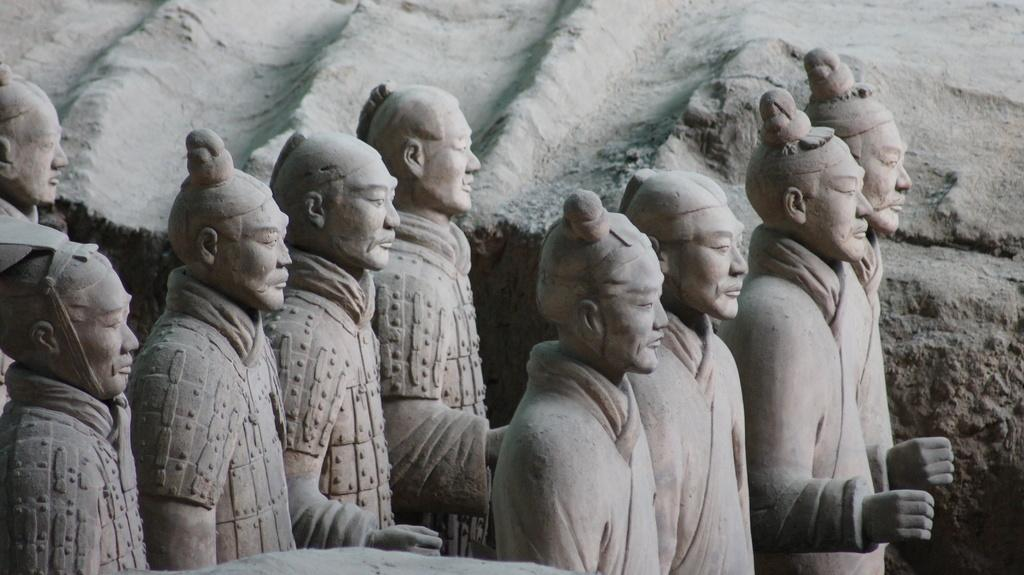What type of objects are depicted in the image? There are sculptures of people in the image. Can you describe the subjects of the sculptures? The sculptures are of people, but specific details about their appearance or actions are not provided. What medium might have been used to create these sculptures? The medium used to create the sculptures is not mentioned in the facts, so it cannot be determined. What type of stew is being served in the image? There is no stew present in the image; it features sculptures of people. What hobbies do the people in the sculptures enjoy? The hobbies of the people in the sculptures are not mentioned in the image, as the sculptures do not depict specific actions or activities. 